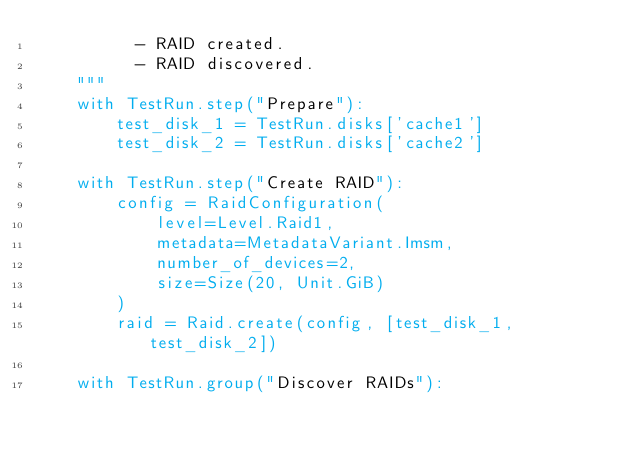Convert code to text. <code><loc_0><loc_0><loc_500><loc_500><_Python_>          - RAID created.
          - RAID discovered.
    """
    with TestRun.step("Prepare"):
        test_disk_1 = TestRun.disks['cache1']
        test_disk_2 = TestRun.disks['cache2']

    with TestRun.step("Create RAID"):
        config = RaidConfiguration(
            level=Level.Raid1,
            metadata=MetadataVariant.Imsm,
            number_of_devices=2,
            size=Size(20, Unit.GiB)
        )
        raid = Raid.create(config, [test_disk_1, test_disk_2])

    with TestRun.group("Discover RAIDs"):</code> 